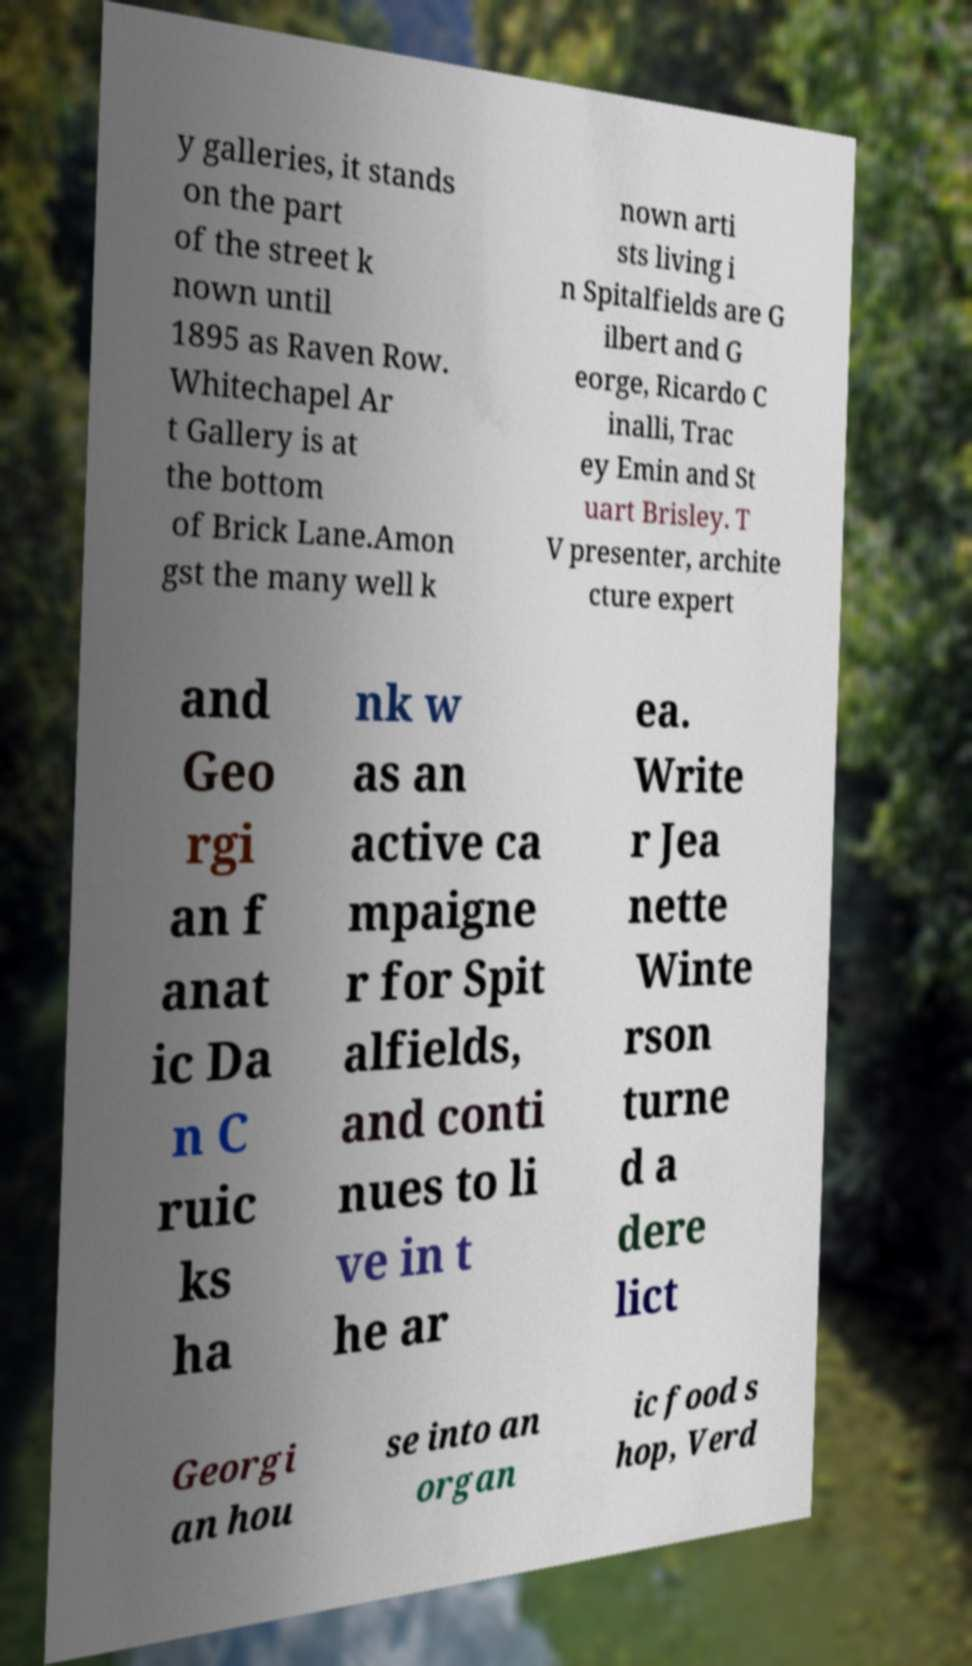I need the written content from this picture converted into text. Can you do that? y galleries, it stands on the part of the street k nown until 1895 as Raven Row. Whitechapel Ar t Gallery is at the bottom of Brick Lane.Amon gst the many well k nown arti sts living i n Spitalfields are G ilbert and G eorge, Ricardo C inalli, Trac ey Emin and St uart Brisley. T V presenter, archite cture expert and Geo rgi an f anat ic Da n C ruic ks ha nk w as an active ca mpaigne r for Spit alfields, and conti nues to li ve in t he ar ea. Write r Jea nette Winte rson turne d a dere lict Georgi an hou se into an organ ic food s hop, Verd 